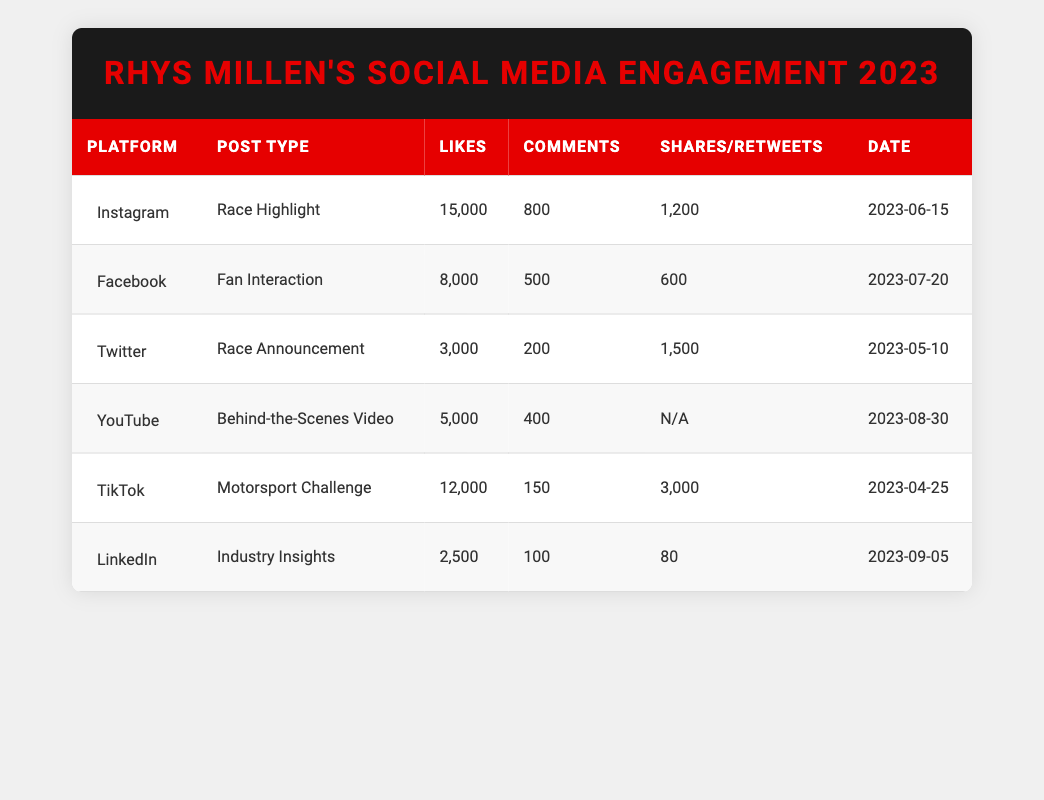What was the total number of likes across all platforms for Rhys Millen's social media engagement in 2023? To find the total number of likes, we sum up the likes from each platform: Instagram (15000) + Facebook (8000) + Twitter (3000) + YouTube (5000) + TikTok (12000) + LinkedIn (2500) = 15000 + 8000 + 3000 + 5000 + 12000 + 2500 = 41500.
Answer: 41500 Which platform had the highest number of shares? In the table, we look at the shares column. Instagram has 1200 shares, Facebook has 600 shares, Twitter has 1500 retweets (counted as shares), YouTube has N/A, TikTok has 3000 shares, and LinkedIn has 80 shares. The highest is TikTok with 3000 shares.
Answer: TikTok Did Rhys Millen have a post type that received more than 500 likes but less than 1000 comments? Checking the table, the Facebook post (Fan Interaction) has 8000 likes and 500 comments, which fits the criteria. The other posts either exceed 1000 likes or 500 comments. Therefore, yes, there is such a post.
Answer: Yes What is the average number of comments across all platforms? To find the average number of comments, we add all the comments: 800 (Instagram) + 500 (Facebook) + 200 (Twitter) + 400 (YouTube) + 150 (TikTok) + 100 (LinkedIn) = 2150. Then, counting the number of platforms (6) gives us an average of 2150 / 6 ≈ 358.33.
Answer: Approximately 358.33 Was there a post type on YouTube with more than 300 likes in 2023? From the table, the YouTube post (Behind-the-Scenes Video) has 5000 likes, which confirms that it exceeds 300 likes.
Answer: Yes Which platform had the least engagement in terms of likes for Rhys Millen's achievements? Comparing the likes across all platforms: Instagram (15000), Facebook (8000), Twitter (3000), YouTube (5000), TikTok (12000), and LinkedIn (2500). LinkedIn has the least likes with 2500.
Answer: LinkedIn 